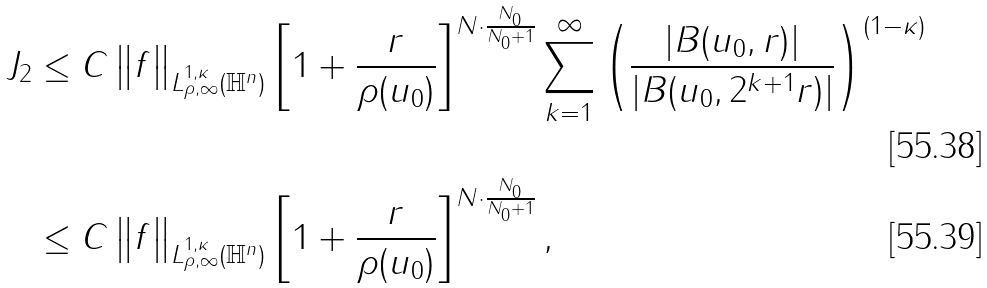<formula> <loc_0><loc_0><loc_500><loc_500>J _ { 2 } & \leq C \left \| f \right \| _ { L ^ { 1 , \kappa } _ { \rho , \infty } ( \mathbb { H } ^ { n } ) } \left [ 1 + \frac { r } { \rho ( u _ { 0 } ) } \right ] ^ { N \cdot \frac { N _ { 0 } } { N _ { 0 } + 1 } } \sum _ { k = 1 } ^ { \infty } \left ( \frac { | B ( u _ { 0 } , r ) | } { | B ( u _ { 0 } , 2 ^ { k + 1 } r ) | } \right ) ^ { ( 1 - \kappa ) } \\ & \leq C \left \| f \right \| _ { L ^ { 1 , \kappa } _ { \rho , \infty } ( \mathbb { H } ^ { n } ) } \left [ 1 + \frac { r } { \rho ( u _ { 0 } ) } \right ] ^ { N \cdot \frac { N _ { 0 } } { N _ { 0 } + 1 } } ,</formula> 